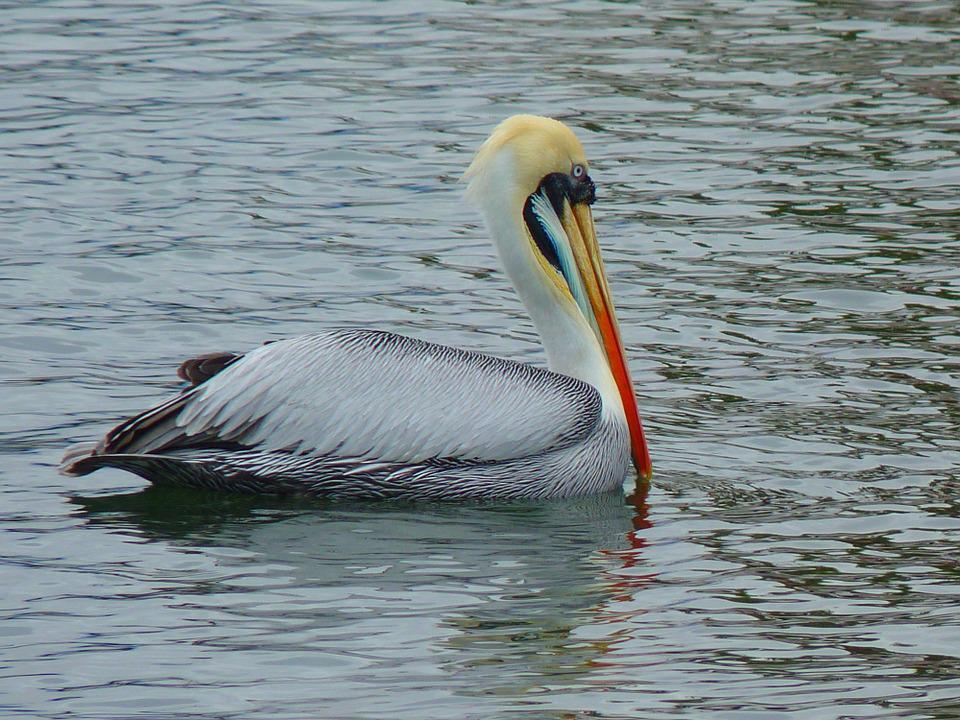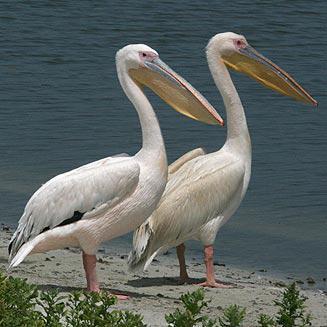The first image is the image on the left, the second image is the image on the right. Assess this claim about the two images: "One image depicts more than one water bird.". Correct or not? Answer yes or no. Yes. 